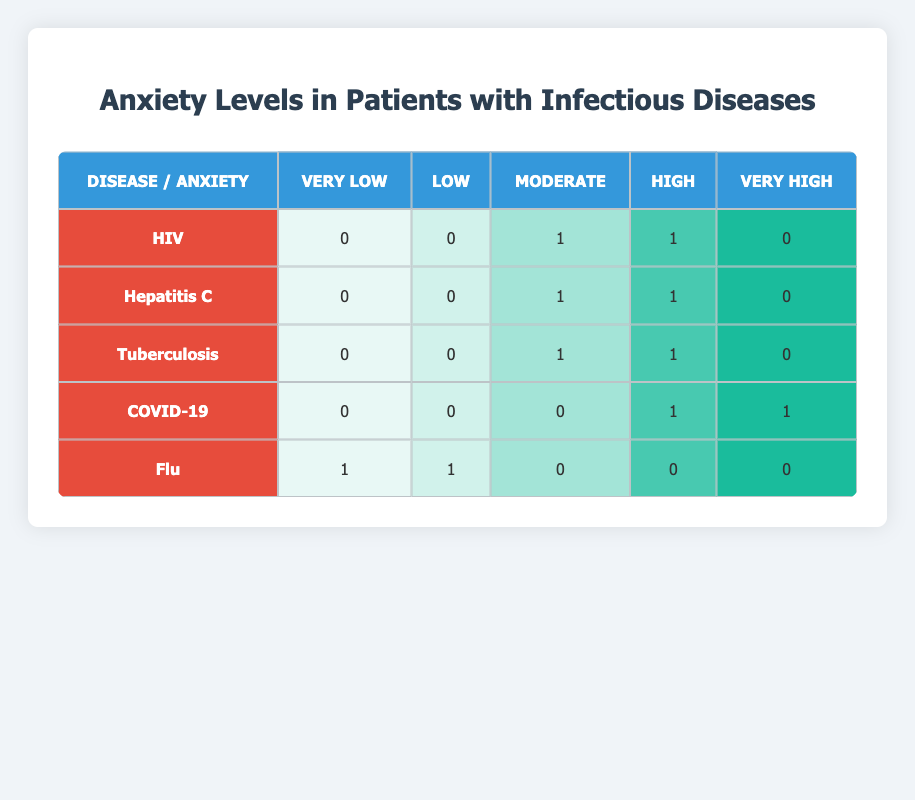What is the anxiety level distribution for HIV patients? According to the table, the distribution of anxiety levels for HIV patients shows 0 for Very Low, 0 for Low, 1 for Moderate, 1 for High, and 0 for Very High. This clearly lays out how many patients fall under each anxiety category.
Answer: Very Low: 0, Low: 0, Moderate: 1, High: 1, Very High: 0 How many patients have reported a Very High anxiety level? By examining the last column of the table for all diseases, we can see that there are two patients who reported Very High anxiety levels, one from COVID-19 and none from other diseases. Therefore, it's straightforward to conclude that there are a total of 2 patients with Very High anxiety.
Answer: 2 Which infectious disease has the highest number of patients at a High anxiety level? When reviewing the data for the High anxiety level across all diseases, both HIV, Hepatitis C, and Tuberculosis have 1 patient each showing High anxiety, while COVID-19 also has 1. None of the others exceed this number. Thus, there is a tie among four diseases with a High anxiety level of 1 patient each.
Answer: HIV, Hepatitis C, Tuberculosis, COVID-19 (all have 1) What is the total number of patients with Low anxiety levels? Looking across the rows categorized as Low anxiety levels, we find that there is 1 patient from Flu, and none from other diseases. Summing these numbers gives a total of just 1 patient with Low anxiety levels.
Answer: 1 Is there any disease that has patients reporting a Moderate anxiety level? By assessing the Moderate anxiety levels throughout the table for each infectious disease, we find patients with Moderate levels in HIV, Hepatitis C, and Tuberculosis. Therefore, the conclusion is yes, there are diseases with Moderate anxiety levels represented.
Answer: Yes How does the number of patients with Very Low anxiety levels relate to the total number of patients for all diseases? The total number of patients is 10, and the table shows that only 1 patient (from Flu) reported Very Low anxiety levels. To find the relationship, we can state that only 10% of the patients fall into the Very Low category, since 1 out of 10 is very low compared to the total.
Answer: 10% Which anxiety level is least reported among all patients across the infectious diseases studied? By observing the recorded anxiety levels across all diseases, it’s clear that the Very Low anxiety level appears only for Flu (1 patient), and all other categories have at least 1 or more. Therefore, Very Low anxiety level is the least reported.
Answer: Very Low What is the average anxiety level for patients suffering from Tuberculosis? Patients with Tuberculosis exhibit a Moderate level (1 patient) as well as a High level (1 patient), which can be assigned numerical values for averaging—Moderate (3) and High (4). Therefore, the average is (3 + 4)/2 = 3.5, indicating the average anxiety excitement for Tuberculosis patients is moderate-high.
Answer: 3.5 